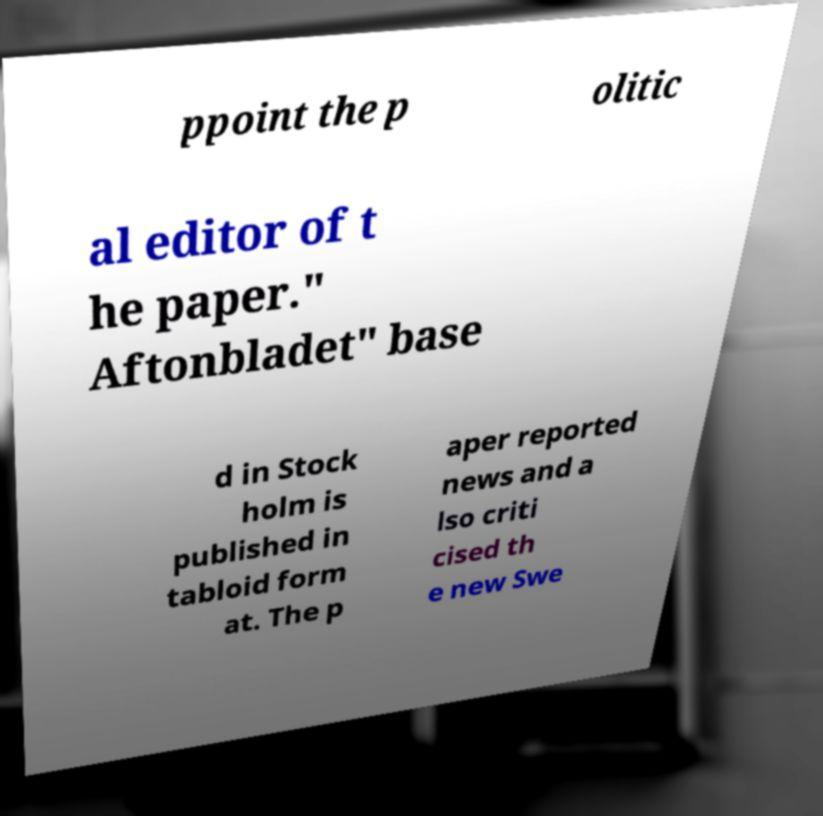There's text embedded in this image that I need extracted. Can you transcribe it verbatim? ppoint the p olitic al editor of t he paper." Aftonbladet" base d in Stock holm is published in tabloid form at. The p aper reported news and a lso criti cised th e new Swe 